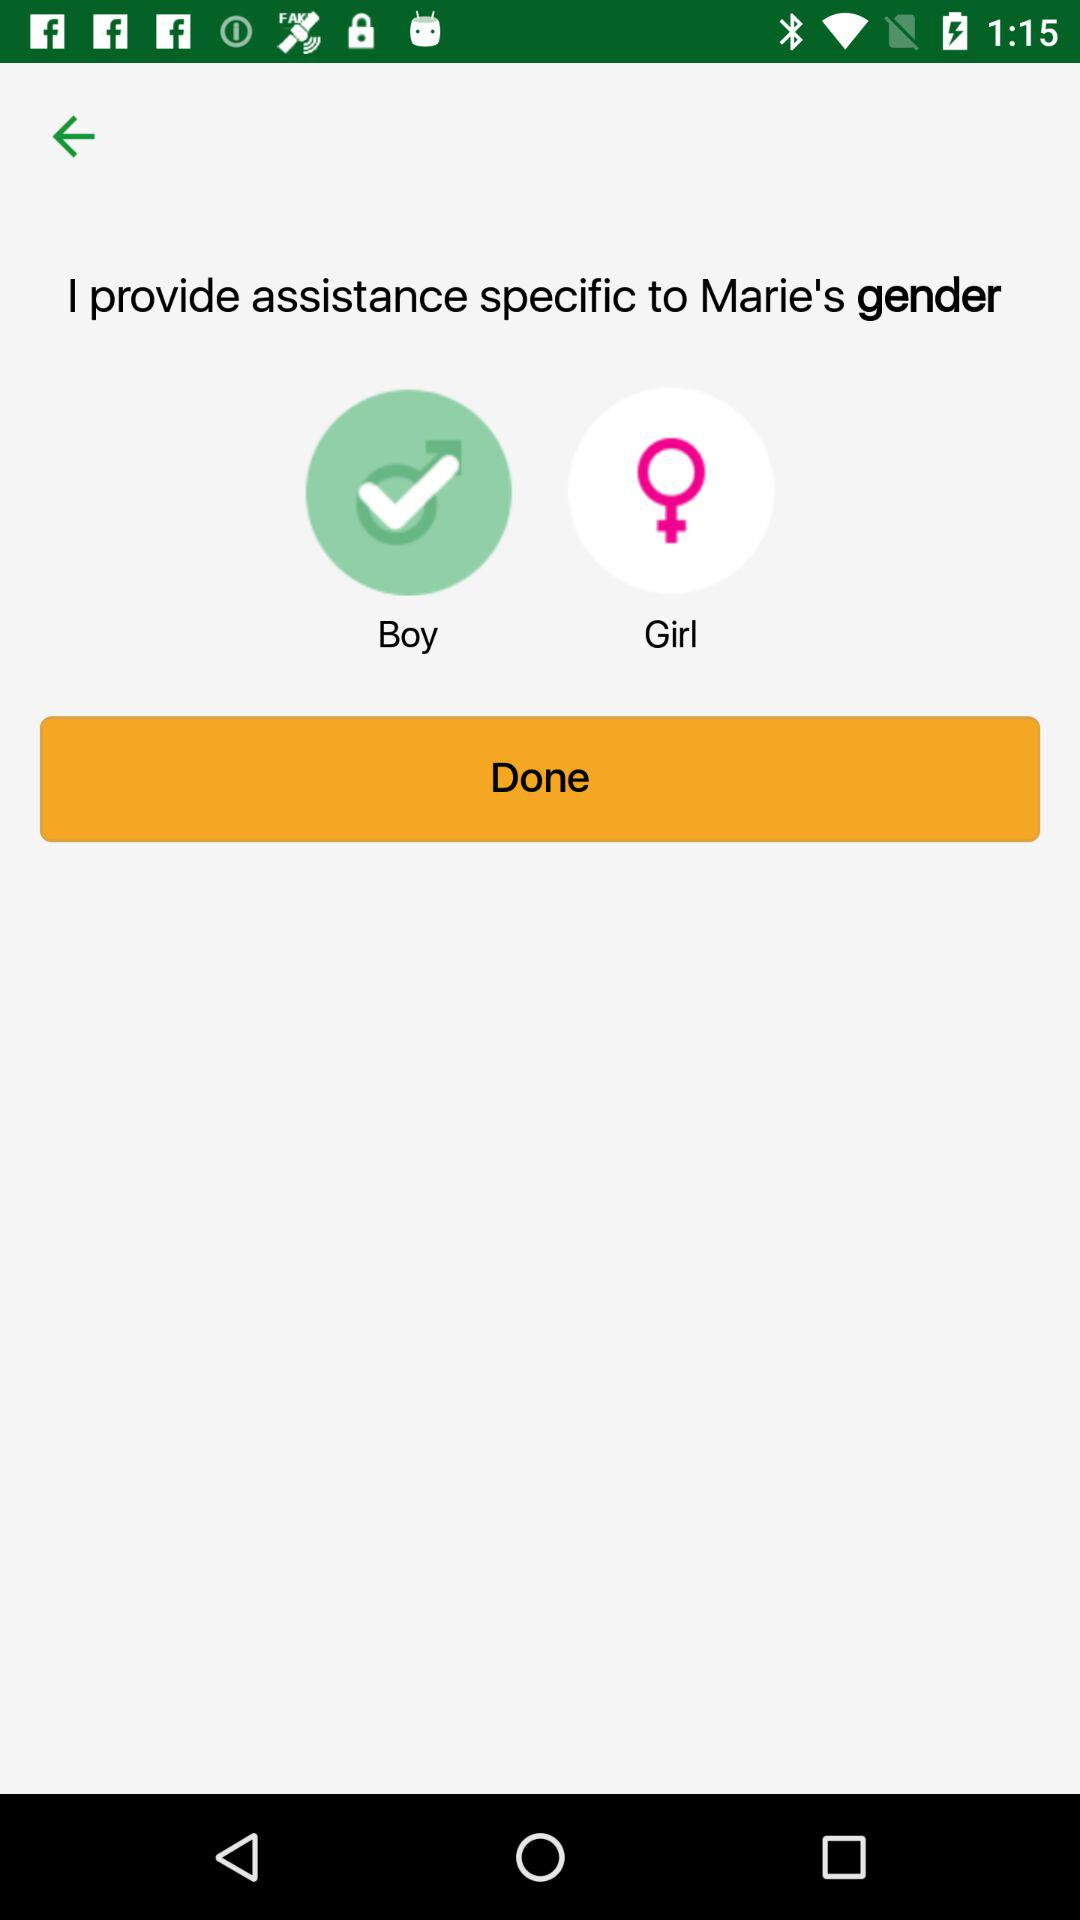What is the person's name? The person's name is Marie. 